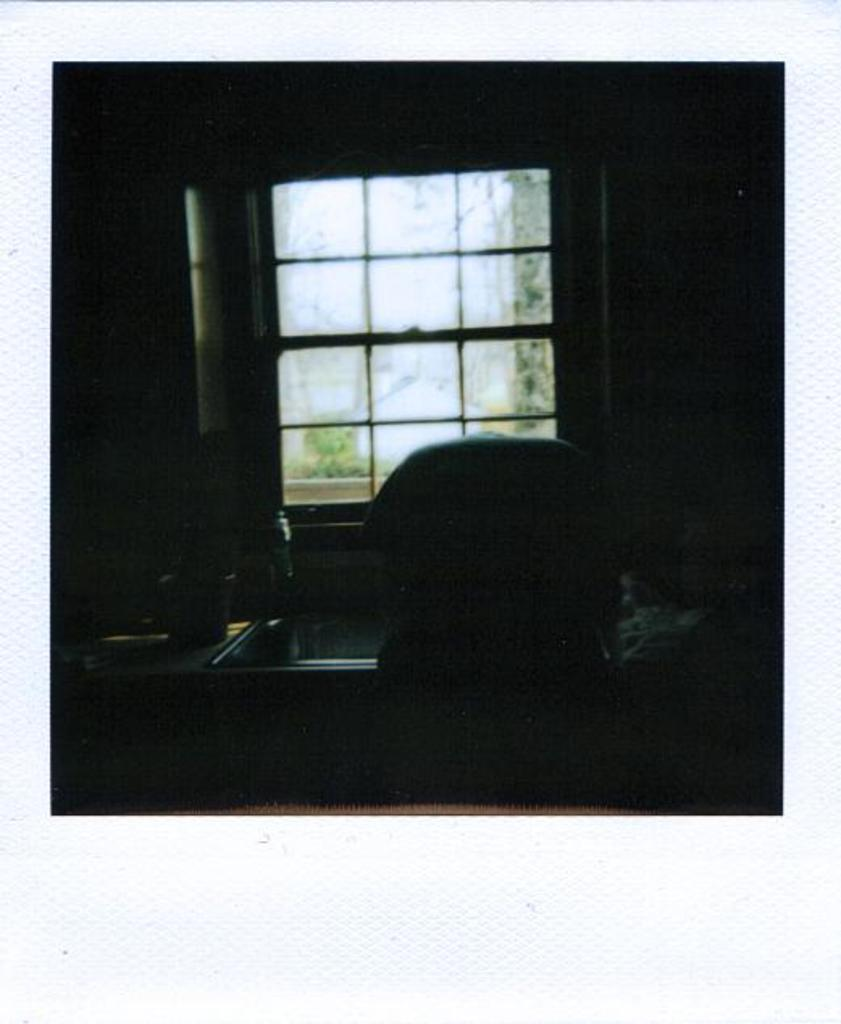What is one of the main features of the image? There is a window in the image. What piece of furniture is present in the image? There is a table in the image. Can you describe any other objects in the image? There are other objects in the image, but their specific details are not provided. How would you describe the lighting in the image? The image is dark. What action is the channel performing in the image? There is no channel present in the image, so it is not possible to answer that question. 